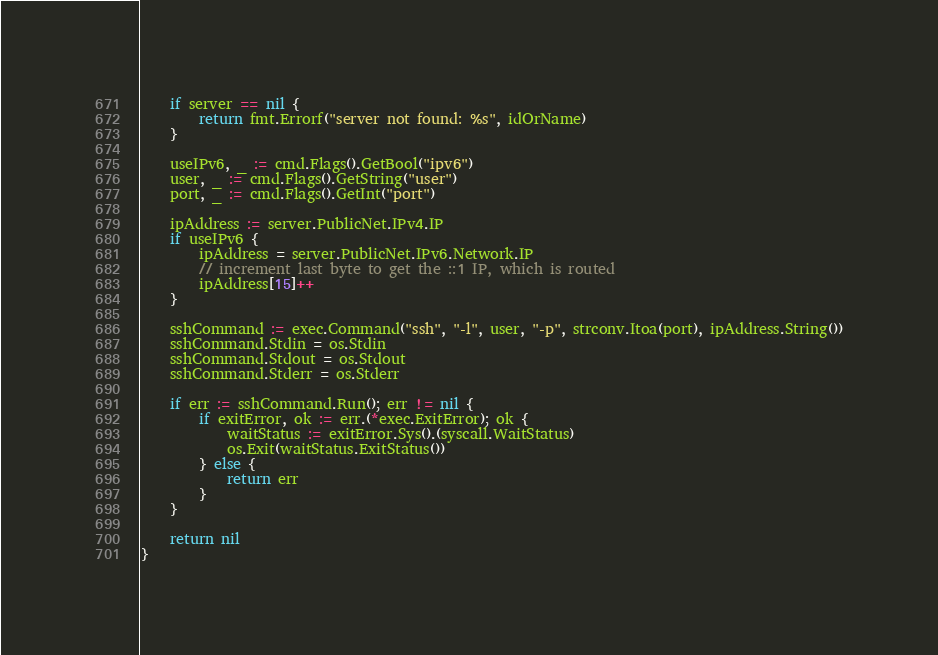<code> <loc_0><loc_0><loc_500><loc_500><_Go_>	if server == nil {
		return fmt.Errorf("server not found: %s", idOrName)
	}

	useIPv6, _ := cmd.Flags().GetBool("ipv6")
	user, _ := cmd.Flags().GetString("user")
	port, _ := cmd.Flags().GetInt("port")

	ipAddress := server.PublicNet.IPv4.IP
	if useIPv6 {
		ipAddress = server.PublicNet.IPv6.Network.IP
		// increment last byte to get the ::1 IP, which is routed
		ipAddress[15]++
	}

	sshCommand := exec.Command("ssh", "-l", user, "-p", strconv.Itoa(port), ipAddress.String())
	sshCommand.Stdin = os.Stdin
	sshCommand.Stdout = os.Stdout
	sshCommand.Stderr = os.Stderr

	if err := sshCommand.Run(); err != nil {
		if exitError, ok := err.(*exec.ExitError); ok {
			waitStatus := exitError.Sys().(syscall.WaitStatus)
			os.Exit(waitStatus.ExitStatus())
		} else {
			return err
		}
	}

	return nil
}
</code> 